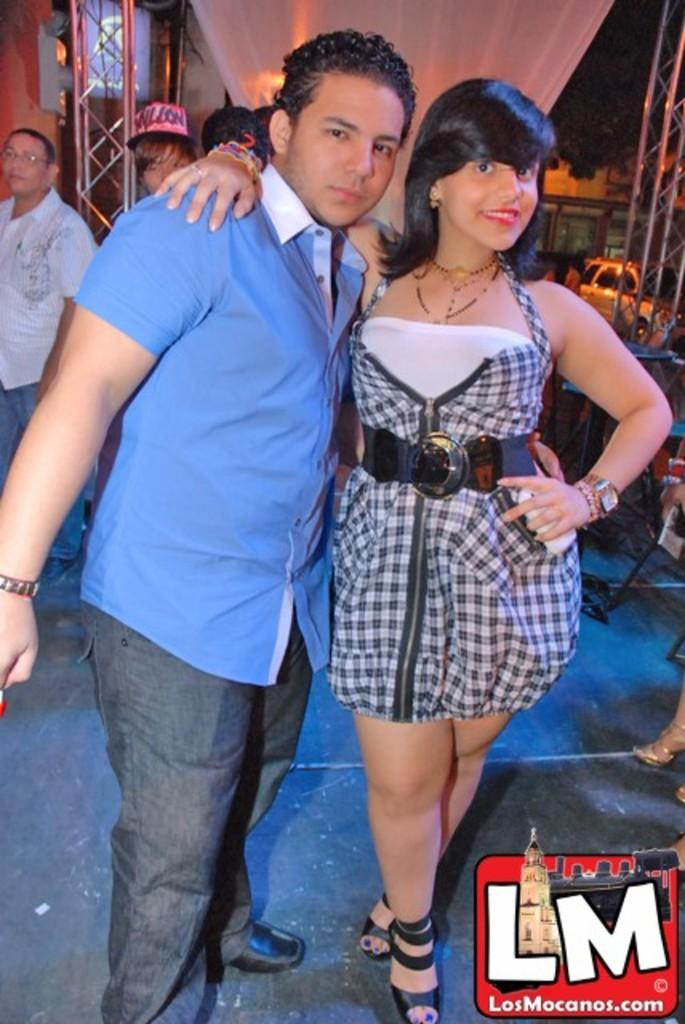Who is in the image? There is a couple in the image. What are the couple doing in the image? The couple is posing for the camera and smiling. Are there any other people in the image besides the couple? Yes, there are other people standing behind the couple. What can be seen in the background of the image? There is a car visible in the background of the image. What type of patch is sewn onto the trousers of the man in the image? There is no information about the man's trousers or any patches in the image. 